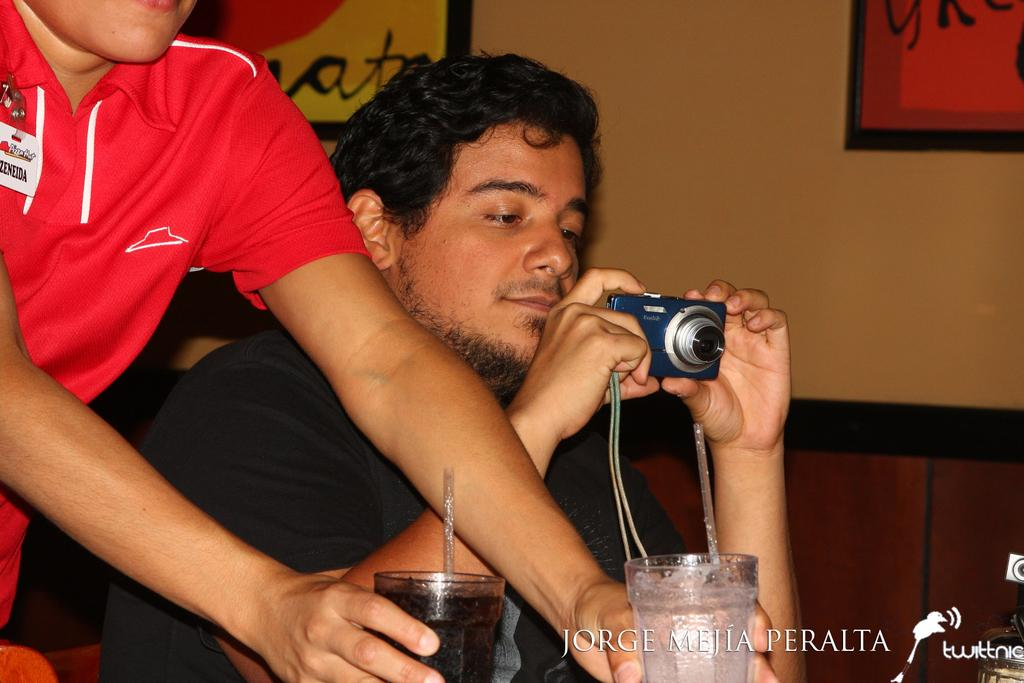What is the man in the image holding? The man in the image is holding a camera. What is the other person in the image holding? The other person in the image is holding two glasses. What type of space suit is the man wearing in the image? There is no space suit or any reference to space in the image; the man is holding a camera. What color is the pickle on the table in the image? There is no pickle present in the image. 